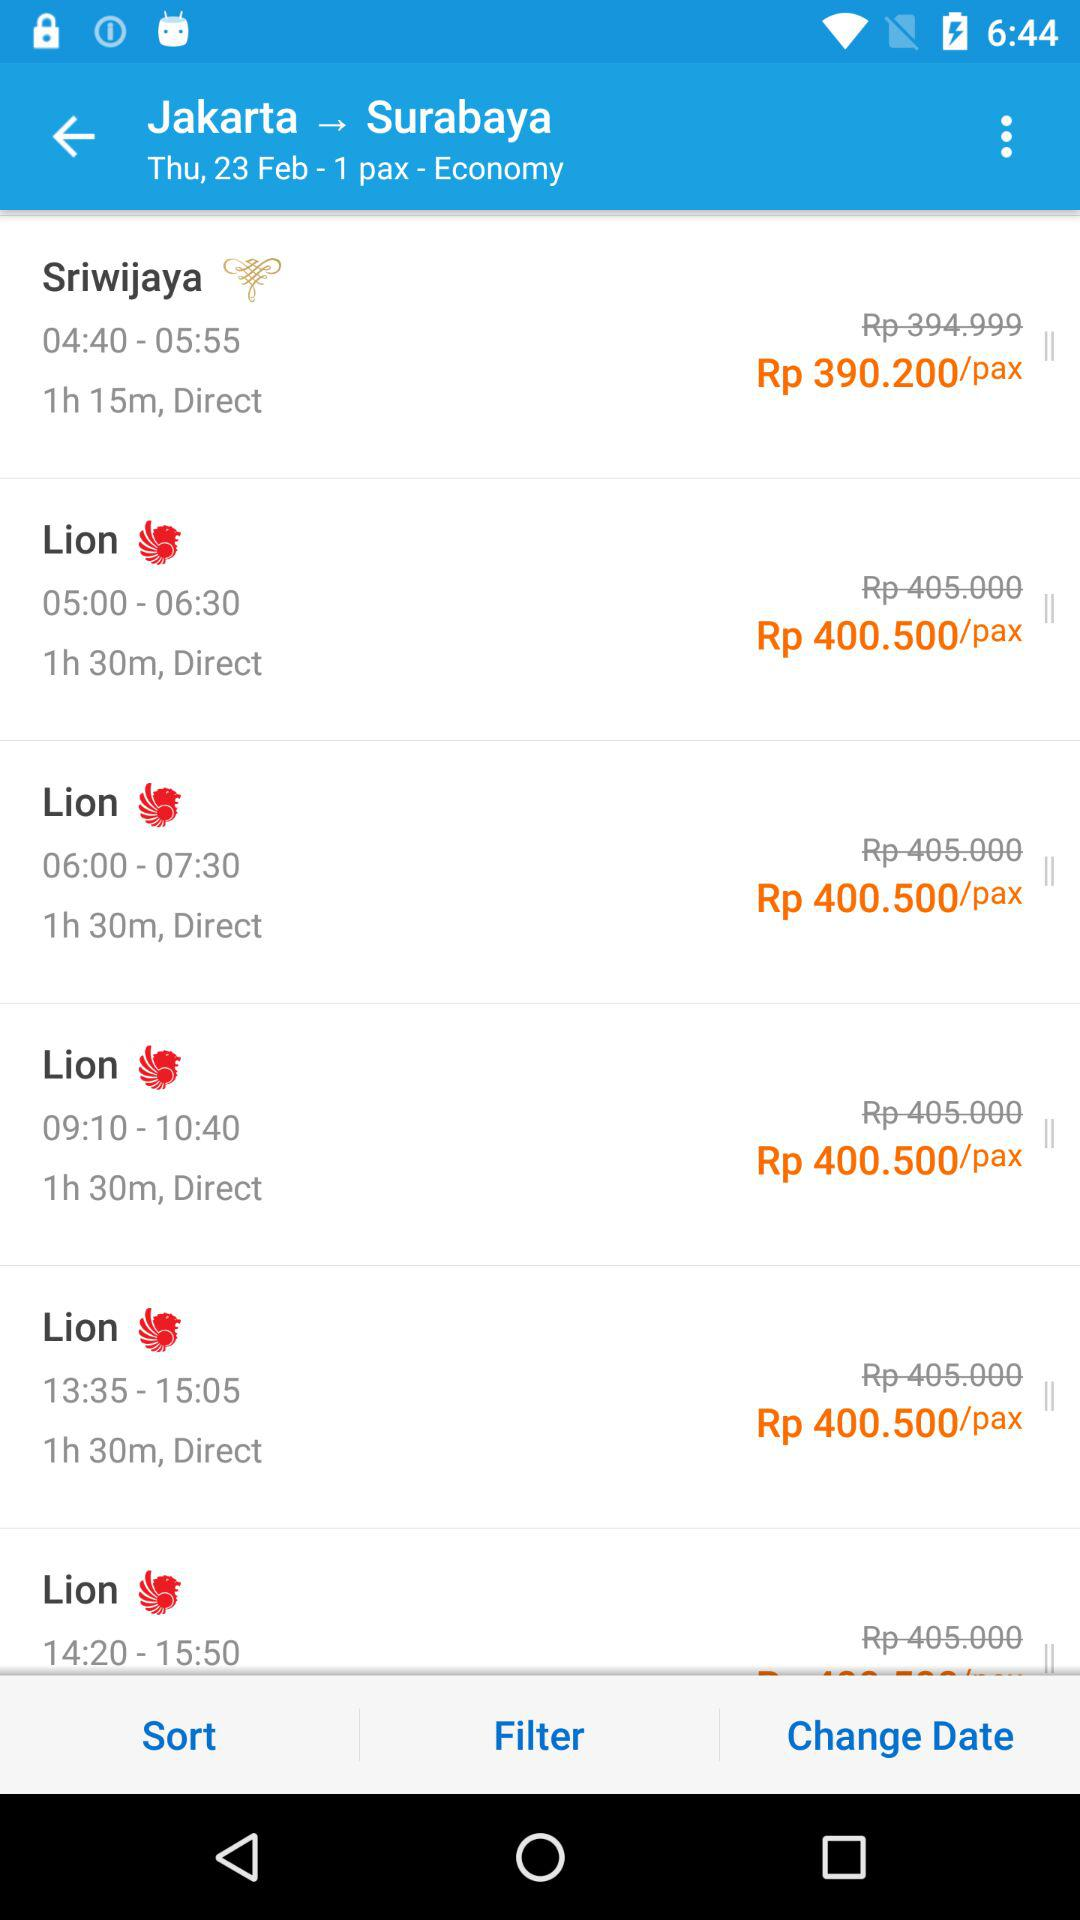What is the destination? The destination is Surabaya. 